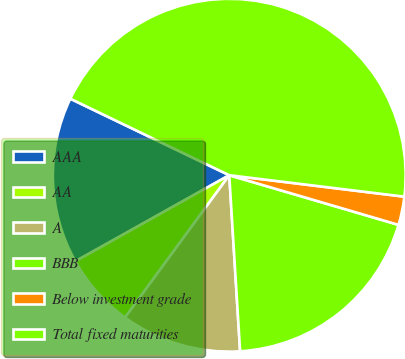<chart> <loc_0><loc_0><loc_500><loc_500><pie_chart><fcel>AAA<fcel>AA<fcel>A<fcel>BBB<fcel>Below investment grade<fcel>Total fixed maturities<nl><fcel>15.26%<fcel>6.82%<fcel>11.04%<fcel>19.48%<fcel>2.6%<fcel>44.8%<nl></chart> 